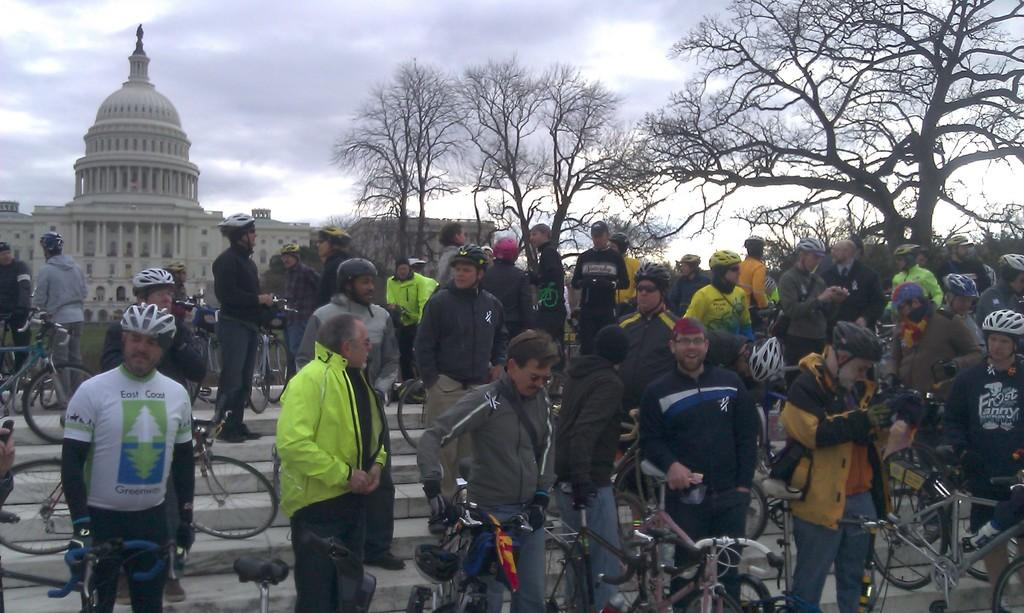What are the people in the image doing? The people in the image are standing on the stairs. What protective gear are some of the people wearing? Some people are wearing helmets. What can be seen in the background of the image? There are trees and a building visible in the background. How would you describe the weather based on the image? The sky is clear, suggesting good weather. What type of part can be seen quivering in the image? There is no part or quivering object present in the image. 